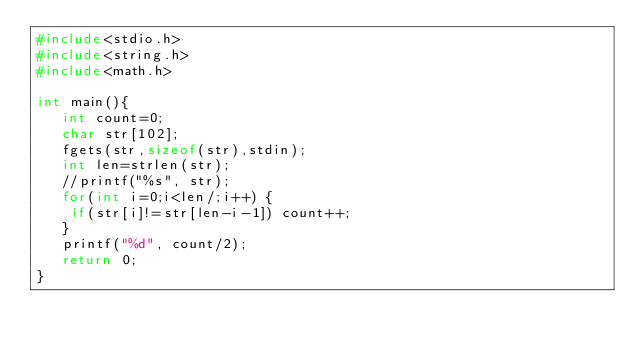Convert code to text. <code><loc_0><loc_0><loc_500><loc_500><_C_>#include<stdio.h>
#include<string.h>
#include<math.h>
 
int main(){
   int count=0;
   char str[102];
   fgets(str,sizeof(str),stdin);
   int len=strlen(str);
   //printf("%s", str);
   for(int i=0;i<len/;i++) {
    if(str[i]!=str[len-i-1]) count++;    
   }
   printf("%d", count/2);
   return 0;
}</code> 